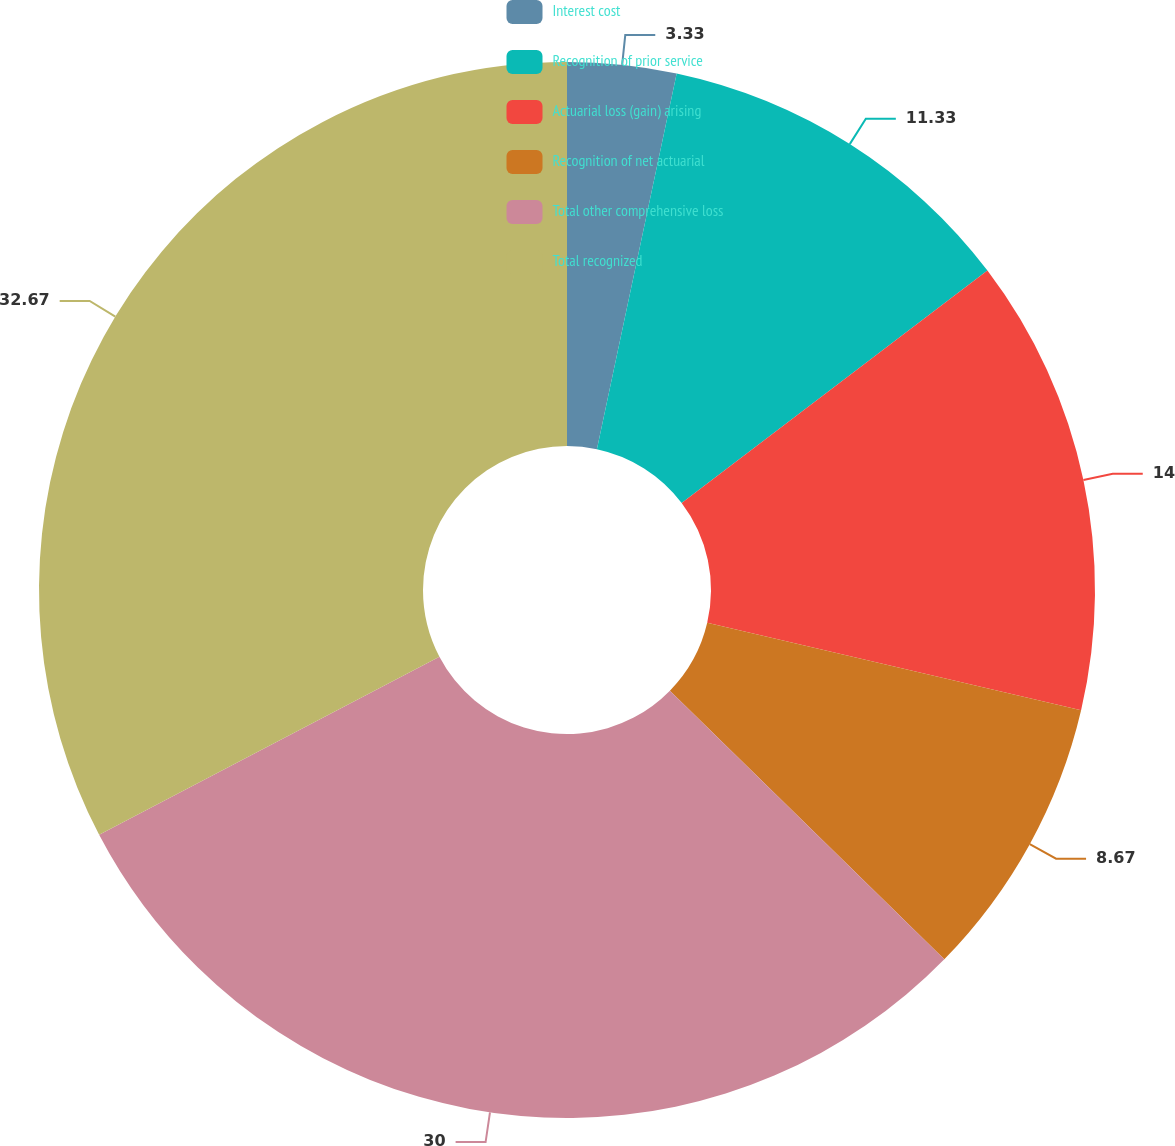Convert chart. <chart><loc_0><loc_0><loc_500><loc_500><pie_chart><fcel>Interest cost<fcel>Recognition of prior service<fcel>Actuarial loss (gain) arising<fcel>Recognition of net actuarial<fcel>Total other comprehensive loss<fcel>Total recognized<nl><fcel>3.33%<fcel>11.33%<fcel>14.0%<fcel>8.67%<fcel>30.0%<fcel>32.67%<nl></chart> 